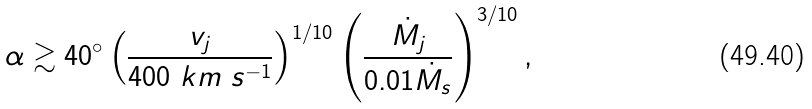Convert formula to latex. <formula><loc_0><loc_0><loc_500><loc_500>\alpha \gtrsim 4 0 ^ { \circ } \left ( \frac { v _ { j } } { 4 0 0 \ k m \ s ^ { - 1 } } \right ) ^ { 1 / 1 0 } \left ( \frac { \dot { M } _ { j } } { 0 . 0 1 \dot { M } _ { s } } \right ) ^ { 3 / 1 0 } ,</formula> 